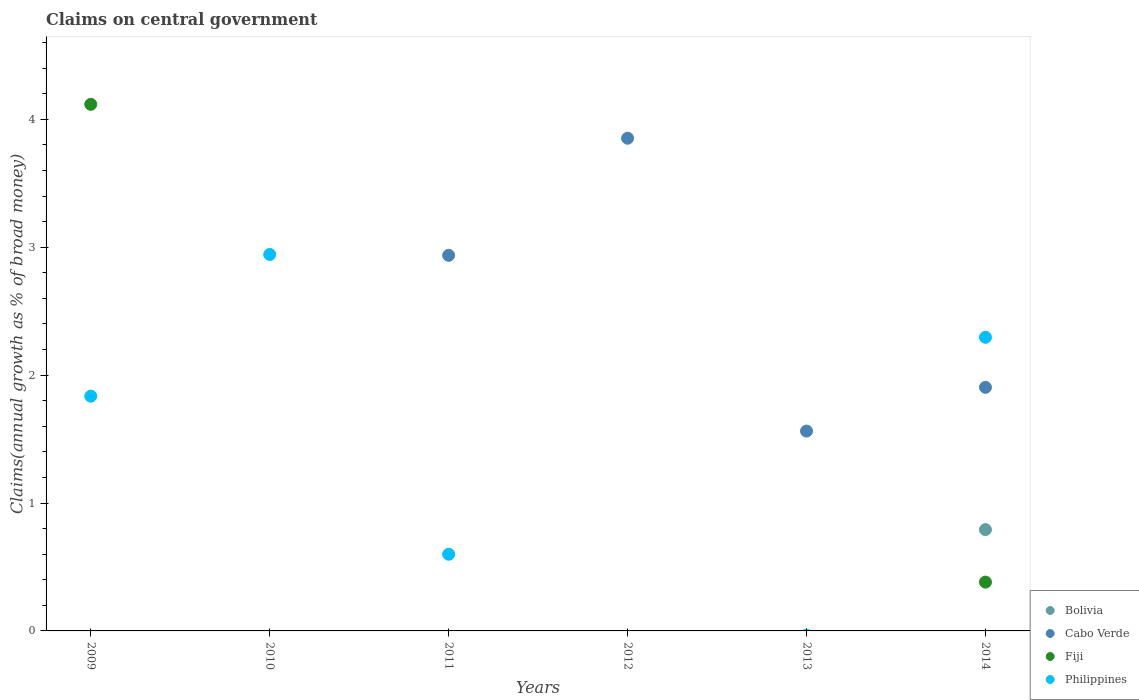How many different coloured dotlines are there?
Your answer should be very brief. 4. Across all years, what is the maximum percentage of broad money claimed on centeral government in Philippines?
Keep it short and to the point. 2.94. Across all years, what is the minimum percentage of broad money claimed on centeral government in Fiji?
Ensure brevity in your answer.  0. What is the total percentage of broad money claimed on centeral government in Philippines in the graph?
Your answer should be very brief. 7.67. What is the difference between the percentage of broad money claimed on centeral government in Cabo Verde in 2013 and that in 2014?
Provide a succinct answer. -0.34. What is the difference between the percentage of broad money claimed on centeral government in Bolivia in 2011 and the percentage of broad money claimed on centeral government in Cabo Verde in 2013?
Give a very brief answer. -1.56. What is the average percentage of broad money claimed on centeral government in Philippines per year?
Keep it short and to the point. 1.28. In the year 2011, what is the difference between the percentage of broad money claimed on centeral government in Cabo Verde and percentage of broad money claimed on centeral government in Philippines?
Keep it short and to the point. 2.34. What is the ratio of the percentage of broad money claimed on centeral government in Philippines in 2010 to that in 2011?
Provide a succinct answer. 4.91. Is the percentage of broad money claimed on centeral government in Cabo Verde in 2013 less than that in 2014?
Offer a terse response. Yes. What is the difference between the highest and the second highest percentage of broad money claimed on centeral government in Cabo Verde?
Provide a short and direct response. 0.92. What is the difference between the highest and the lowest percentage of broad money claimed on centeral government in Bolivia?
Give a very brief answer. 0.79. Is the sum of the percentage of broad money claimed on centeral government in Philippines in 2010 and 2014 greater than the maximum percentage of broad money claimed on centeral government in Bolivia across all years?
Offer a terse response. Yes. Is it the case that in every year, the sum of the percentage of broad money claimed on centeral government in Bolivia and percentage of broad money claimed on centeral government in Philippines  is greater than the sum of percentage of broad money claimed on centeral government in Cabo Verde and percentage of broad money claimed on centeral government in Fiji?
Your response must be concise. No. Is the percentage of broad money claimed on centeral government in Cabo Verde strictly greater than the percentage of broad money claimed on centeral government in Fiji over the years?
Provide a short and direct response. No. Is the percentage of broad money claimed on centeral government in Philippines strictly less than the percentage of broad money claimed on centeral government in Bolivia over the years?
Ensure brevity in your answer.  No. How many dotlines are there?
Your answer should be compact. 4. Are the values on the major ticks of Y-axis written in scientific E-notation?
Your response must be concise. No. Does the graph contain grids?
Make the answer very short. No. Where does the legend appear in the graph?
Make the answer very short. Bottom right. How many legend labels are there?
Keep it short and to the point. 4. How are the legend labels stacked?
Make the answer very short. Vertical. What is the title of the graph?
Your answer should be very brief. Claims on central government. What is the label or title of the Y-axis?
Make the answer very short. Claims(annual growth as % of broad money). What is the Claims(annual growth as % of broad money) in Cabo Verde in 2009?
Your response must be concise. 0. What is the Claims(annual growth as % of broad money) in Fiji in 2009?
Your answer should be compact. 4.12. What is the Claims(annual growth as % of broad money) of Philippines in 2009?
Your answer should be compact. 1.84. What is the Claims(annual growth as % of broad money) in Bolivia in 2010?
Your response must be concise. 0. What is the Claims(annual growth as % of broad money) of Cabo Verde in 2010?
Give a very brief answer. 0. What is the Claims(annual growth as % of broad money) of Philippines in 2010?
Your response must be concise. 2.94. What is the Claims(annual growth as % of broad money) of Bolivia in 2011?
Offer a very short reply. 0. What is the Claims(annual growth as % of broad money) of Cabo Verde in 2011?
Provide a succinct answer. 2.94. What is the Claims(annual growth as % of broad money) of Philippines in 2011?
Keep it short and to the point. 0.6. What is the Claims(annual growth as % of broad money) in Cabo Verde in 2012?
Provide a short and direct response. 3.85. What is the Claims(annual growth as % of broad money) of Philippines in 2012?
Keep it short and to the point. 0. What is the Claims(annual growth as % of broad money) in Cabo Verde in 2013?
Your answer should be very brief. 1.56. What is the Claims(annual growth as % of broad money) of Fiji in 2013?
Make the answer very short. 0. What is the Claims(annual growth as % of broad money) of Philippines in 2013?
Provide a short and direct response. 0. What is the Claims(annual growth as % of broad money) in Bolivia in 2014?
Keep it short and to the point. 0.79. What is the Claims(annual growth as % of broad money) in Cabo Verde in 2014?
Keep it short and to the point. 1.9. What is the Claims(annual growth as % of broad money) in Fiji in 2014?
Make the answer very short. 0.38. What is the Claims(annual growth as % of broad money) of Philippines in 2014?
Make the answer very short. 2.3. Across all years, what is the maximum Claims(annual growth as % of broad money) of Bolivia?
Your response must be concise. 0.79. Across all years, what is the maximum Claims(annual growth as % of broad money) of Cabo Verde?
Provide a short and direct response. 3.85. Across all years, what is the maximum Claims(annual growth as % of broad money) of Fiji?
Your answer should be compact. 4.12. Across all years, what is the maximum Claims(annual growth as % of broad money) of Philippines?
Keep it short and to the point. 2.94. Across all years, what is the minimum Claims(annual growth as % of broad money) in Bolivia?
Your answer should be compact. 0. Across all years, what is the minimum Claims(annual growth as % of broad money) of Fiji?
Keep it short and to the point. 0. Across all years, what is the minimum Claims(annual growth as % of broad money) in Philippines?
Provide a short and direct response. 0. What is the total Claims(annual growth as % of broad money) of Bolivia in the graph?
Your response must be concise. 0.79. What is the total Claims(annual growth as % of broad money) in Cabo Verde in the graph?
Your answer should be compact. 10.26. What is the total Claims(annual growth as % of broad money) in Fiji in the graph?
Provide a succinct answer. 4.5. What is the total Claims(annual growth as % of broad money) in Philippines in the graph?
Your answer should be compact. 7.67. What is the difference between the Claims(annual growth as % of broad money) in Philippines in 2009 and that in 2010?
Offer a terse response. -1.11. What is the difference between the Claims(annual growth as % of broad money) of Philippines in 2009 and that in 2011?
Provide a succinct answer. 1.24. What is the difference between the Claims(annual growth as % of broad money) in Fiji in 2009 and that in 2014?
Keep it short and to the point. 3.74. What is the difference between the Claims(annual growth as % of broad money) of Philippines in 2009 and that in 2014?
Offer a very short reply. -0.46. What is the difference between the Claims(annual growth as % of broad money) in Philippines in 2010 and that in 2011?
Make the answer very short. 2.34. What is the difference between the Claims(annual growth as % of broad money) of Philippines in 2010 and that in 2014?
Keep it short and to the point. 0.65. What is the difference between the Claims(annual growth as % of broad money) in Cabo Verde in 2011 and that in 2012?
Give a very brief answer. -0.92. What is the difference between the Claims(annual growth as % of broad money) in Cabo Verde in 2011 and that in 2013?
Your response must be concise. 1.37. What is the difference between the Claims(annual growth as % of broad money) of Cabo Verde in 2011 and that in 2014?
Keep it short and to the point. 1.03. What is the difference between the Claims(annual growth as % of broad money) in Philippines in 2011 and that in 2014?
Your answer should be very brief. -1.7. What is the difference between the Claims(annual growth as % of broad money) in Cabo Verde in 2012 and that in 2013?
Give a very brief answer. 2.29. What is the difference between the Claims(annual growth as % of broad money) in Cabo Verde in 2012 and that in 2014?
Offer a terse response. 1.95. What is the difference between the Claims(annual growth as % of broad money) in Cabo Verde in 2013 and that in 2014?
Ensure brevity in your answer.  -0.34. What is the difference between the Claims(annual growth as % of broad money) of Fiji in 2009 and the Claims(annual growth as % of broad money) of Philippines in 2010?
Offer a very short reply. 1.17. What is the difference between the Claims(annual growth as % of broad money) of Fiji in 2009 and the Claims(annual growth as % of broad money) of Philippines in 2011?
Offer a terse response. 3.52. What is the difference between the Claims(annual growth as % of broad money) of Fiji in 2009 and the Claims(annual growth as % of broad money) of Philippines in 2014?
Keep it short and to the point. 1.82. What is the difference between the Claims(annual growth as % of broad money) in Cabo Verde in 2011 and the Claims(annual growth as % of broad money) in Fiji in 2014?
Ensure brevity in your answer.  2.56. What is the difference between the Claims(annual growth as % of broad money) in Cabo Verde in 2011 and the Claims(annual growth as % of broad money) in Philippines in 2014?
Give a very brief answer. 0.64. What is the difference between the Claims(annual growth as % of broad money) in Cabo Verde in 2012 and the Claims(annual growth as % of broad money) in Fiji in 2014?
Offer a very short reply. 3.47. What is the difference between the Claims(annual growth as % of broad money) of Cabo Verde in 2012 and the Claims(annual growth as % of broad money) of Philippines in 2014?
Offer a very short reply. 1.56. What is the difference between the Claims(annual growth as % of broad money) of Cabo Verde in 2013 and the Claims(annual growth as % of broad money) of Fiji in 2014?
Provide a succinct answer. 1.18. What is the difference between the Claims(annual growth as % of broad money) in Cabo Verde in 2013 and the Claims(annual growth as % of broad money) in Philippines in 2014?
Provide a short and direct response. -0.73. What is the average Claims(annual growth as % of broad money) of Bolivia per year?
Ensure brevity in your answer.  0.13. What is the average Claims(annual growth as % of broad money) in Cabo Verde per year?
Ensure brevity in your answer.  1.71. What is the average Claims(annual growth as % of broad money) of Fiji per year?
Offer a terse response. 0.75. What is the average Claims(annual growth as % of broad money) of Philippines per year?
Provide a short and direct response. 1.28. In the year 2009, what is the difference between the Claims(annual growth as % of broad money) of Fiji and Claims(annual growth as % of broad money) of Philippines?
Provide a short and direct response. 2.28. In the year 2011, what is the difference between the Claims(annual growth as % of broad money) of Cabo Verde and Claims(annual growth as % of broad money) of Philippines?
Offer a terse response. 2.34. In the year 2014, what is the difference between the Claims(annual growth as % of broad money) in Bolivia and Claims(annual growth as % of broad money) in Cabo Verde?
Ensure brevity in your answer.  -1.11. In the year 2014, what is the difference between the Claims(annual growth as % of broad money) in Bolivia and Claims(annual growth as % of broad money) in Fiji?
Provide a succinct answer. 0.41. In the year 2014, what is the difference between the Claims(annual growth as % of broad money) in Bolivia and Claims(annual growth as % of broad money) in Philippines?
Your answer should be very brief. -1.5. In the year 2014, what is the difference between the Claims(annual growth as % of broad money) of Cabo Verde and Claims(annual growth as % of broad money) of Fiji?
Provide a short and direct response. 1.52. In the year 2014, what is the difference between the Claims(annual growth as % of broad money) in Cabo Verde and Claims(annual growth as % of broad money) in Philippines?
Give a very brief answer. -0.39. In the year 2014, what is the difference between the Claims(annual growth as % of broad money) of Fiji and Claims(annual growth as % of broad money) of Philippines?
Provide a succinct answer. -1.91. What is the ratio of the Claims(annual growth as % of broad money) of Philippines in 2009 to that in 2010?
Your answer should be very brief. 0.62. What is the ratio of the Claims(annual growth as % of broad money) in Philippines in 2009 to that in 2011?
Provide a short and direct response. 3.06. What is the ratio of the Claims(annual growth as % of broad money) in Fiji in 2009 to that in 2014?
Provide a short and direct response. 10.79. What is the ratio of the Claims(annual growth as % of broad money) in Philippines in 2009 to that in 2014?
Your response must be concise. 0.8. What is the ratio of the Claims(annual growth as % of broad money) in Philippines in 2010 to that in 2011?
Keep it short and to the point. 4.91. What is the ratio of the Claims(annual growth as % of broad money) in Philippines in 2010 to that in 2014?
Make the answer very short. 1.28. What is the ratio of the Claims(annual growth as % of broad money) of Cabo Verde in 2011 to that in 2012?
Offer a very short reply. 0.76. What is the ratio of the Claims(annual growth as % of broad money) in Cabo Verde in 2011 to that in 2013?
Ensure brevity in your answer.  1.88. What is the ratio of the Claims(annual growth as % of broad money) in Cabo Verde in 2011 to that in 2014?
Keep it short and to the point. 1.54. What is the ratio of the Claims(annual growth as % of broad money) of Philippines in 2011 to that in 2014?
Make the answer very short. 0.26. What is the ratio of the Claims(annual growth as % of broad money) of Cabo Verde in 2012 to that in 2013?
Your answer should be very brief. 2.47. What is the ratio of the Claims(annual growth as % of broad money) of Cabo Verde in 2012 to that in 2014?
Provide a short and direct response. 2.02. What is the ratio of the Claims(annual growth as % of broad money) of Cabo Verde in 2013 to that in 2014?
Keep it short and to the point. 0.82. What is the difference between the highest and the second highest Claims(annual growth as % of broad money) in Cabo Verde?
Provide a short and direct response. 0.92. What is the difference between the highest and the second highest Claims(annual growth as % of broad money) in Philippines?
Provide a succinct answer. 0.65. What is the difference between the highest and the lowest Claims(annual growth as % of broad money) in Bolivia?
Offer a terse response. 0.79. What is the difference between the highest and the lowest Claims(annual growth as % of broad money) of Cabo Verde?
Make the answer very short. 3.85. What is the difference between the highest and the lowest Claims(annual growth as % of broad money) in Fiji?
Give a very brief answer. 4.12. What is the difference between the highest and the lowest Claims(annual growth as % of broad money) in Philippines?
Offer a very short reply. 2.94. 